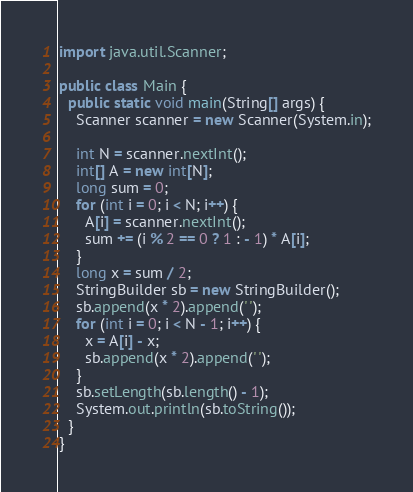<code> <loc_0><loc_0><loc_500><loc_500><_Java_>import java.util.Scanner;

public class Main {
  public static void main(String[] args) {
    Scanner scanner = new Scanner(System.in);

    int N = scanner.nextInt();
    int[] A = new int[N];
    long sum = 0;
    for (int i = 0; i < N; i++) {
      A[i] = scanner.nextInt();
      sum += (i % 2 == 0 ? 1 : - 1) * A[i];
    }
    long x = sum / 2;
    StringBuilder sb = new StringBuilder();
    sb.append(x * 2).append(' ');
    for (int i = 0; i < N - 1; i++) {
      x = A[i] - x;
      sb.append(x * 2).append(' ');
    }
    sb.setLength(sb.length() - 1);
    System.out.println(sb.toString());
  }
}
</code> 